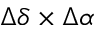<formula> <loc_0><loc_0><loc_500><loc_500>\Delta \delta \times \Delta \alpha</formula> 